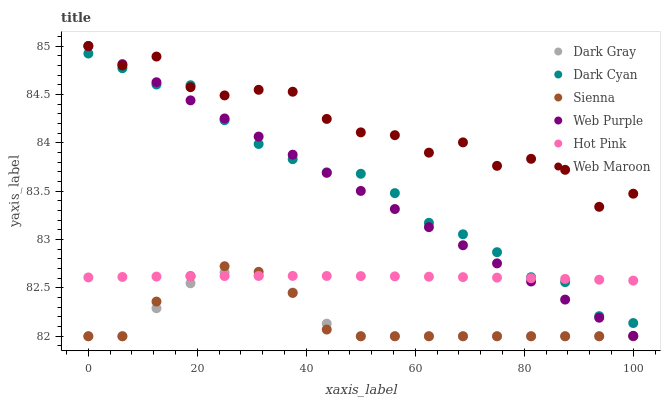Does Dark Gray have the minimum area under the curve?
Answer yes or no. Yes. Does Web Maroon have the maximum area under the curve?
Answer yes or no. Yes. Does Hot Pink have the minimum area under the curve?
Answer yes or no. No. Does Hot Pink have the maximum area under the curve?
Answer yes or no. No. Is Web Purple the smoothest?
Answer yes or no. Yes. Is Web Maroon the roughest?
Answer yes or no. Yes. Is Hot Pink the smoothest?
Answer yes or no. No. Is Hot Pink the roughest?
Answer yes or no. No. Does Sienna have the lowest value?
Answer yes or no. Yes. Does Hot Pink have the lowest value?
Answer yes or no. No. Does Web Purple have the highest value?
Answer yes or no. Yes. Does Hot Pink have the highest value?
Answer yes or no. No. Is Sienna less than Web Maroon?
Answer yes or no. Yes. Is Dark Cyan greater than Dark Gray?
Answer yes or no. Yes. Does Web Maroon intersect Web Purple?
Answer yes or no. Yes. Is Web Maroon less than Web Purple?
Answer yes or no. No. Is Web Maroon greater than Web Purple?
Answer yes or no. No. Does Sienna intersect Web Maroon?
Answer yes or no. No. 